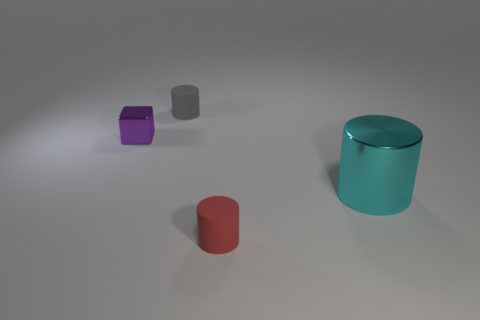Add 1 big cyan shiny objects. How many objects exist? 5 Subtract all cylinders. How many objects are left? 1 Add 1 metallic cylinders. How many metallic cylinders exist? 2 Subtract 0 red spheres. How many objects are left? 4 Subtract all gray things. Subtract all purple blocks. How many objects are left? 2 Add 4 cyan cylinders. How many cyan cylinders are left? 5 